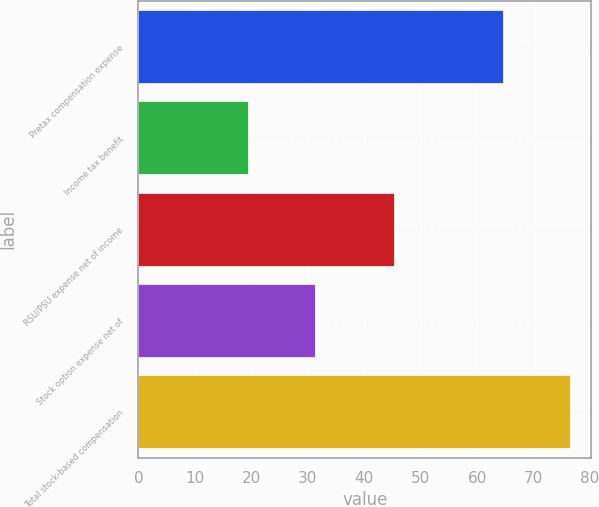<chart> <loc_0><loc_0><loc_500><loc_500><bar_chart><fcel>Pretax compensation expense<fcel>Income tax benefit<fcel>RSU/PSU expense net of income<fcel>Stock option expense net of<fcel>Total stock-based compensation<nl><fcel>64.6<fcel>19.4<fcel>45.2<fcel>31.2<fcel>76.4<nl></chart> 